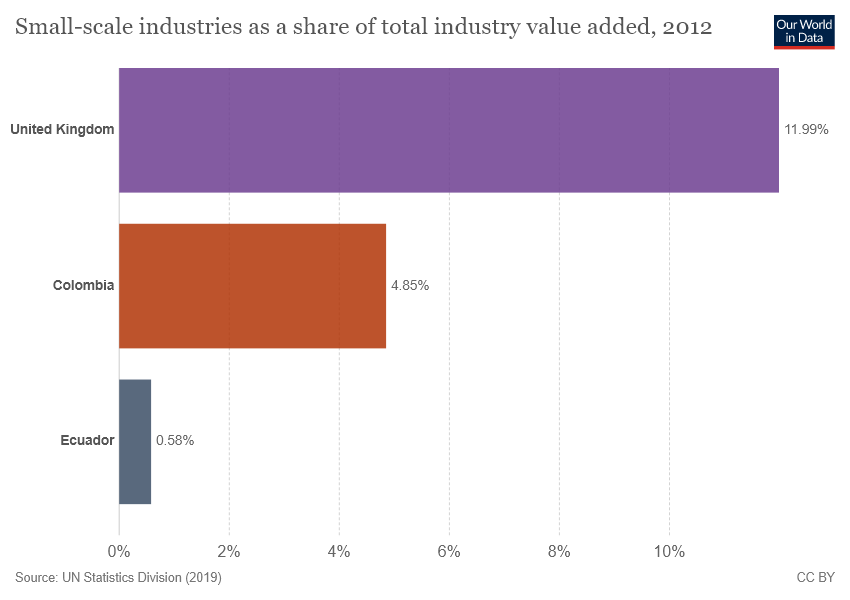Draw attention to some important aspects in this diagram. The average of the bottom two countries is 2.715. The value shown for Colombia is 4.85. 